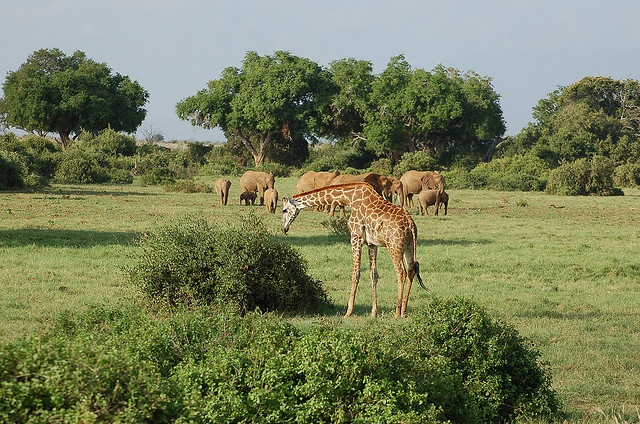Describe the objects in this image and their specific colors. I can see giraffe in lightgray, tan, and brown tones, elephant in lightgray, tan, gray, and maroon tones, elephant in lightgray, maroon, tan, and black tones, elephant in lightgray, tan, and olive tones, and elephant in lightgray, black, tan, and maroon tones in this image. 